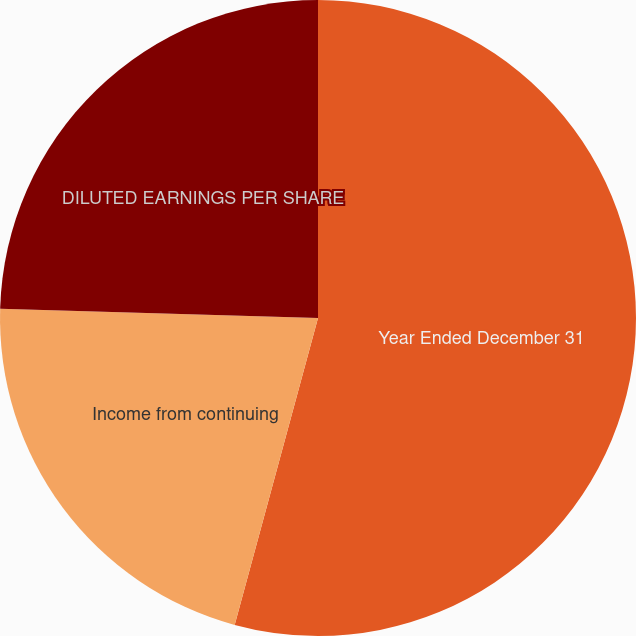Convert chart. <chart><loc_0><loc_0><loc_500><loc_500><pie_chart><fcel>Year Ended December 31<fcel>Income from continuing<fcel>DILUTED EARNINGS PER SHARE<nl><fcel>54.22%<fcel>21.24%<fcel>24.54%<nl></chart> 